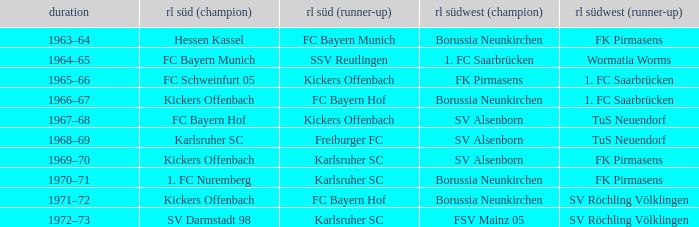In which season did sv darmstadt 98 finish at rl süd (1st)? 1972–73. 